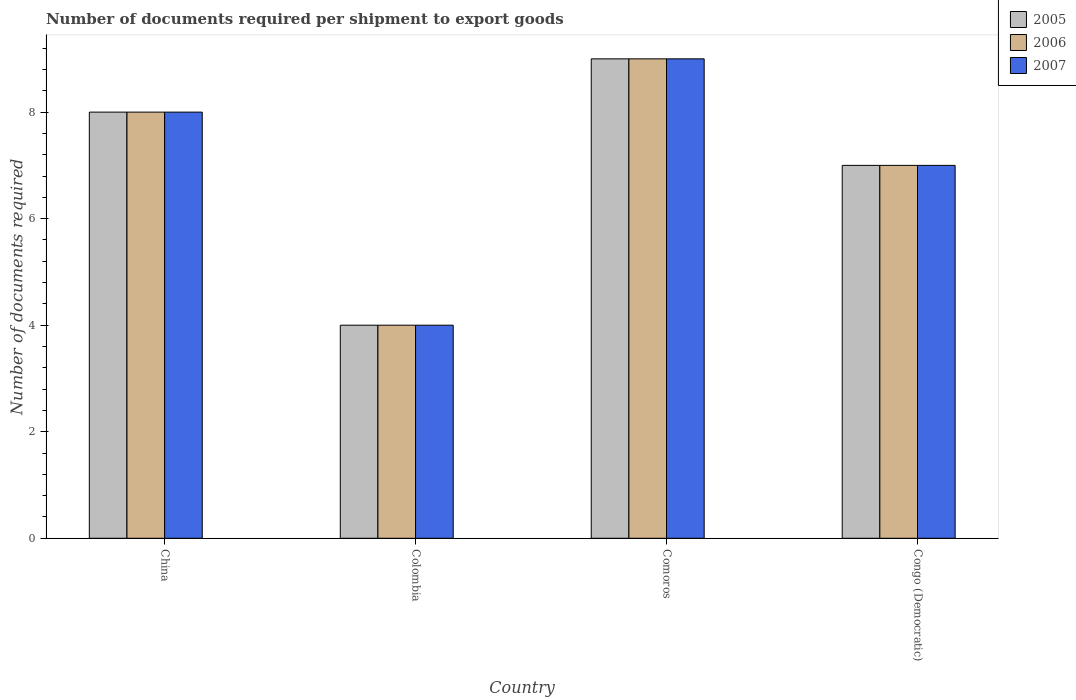How many different coloured bars are there?
Your response must be concise. 3. How many groups of bars are there?
Your answer should be very brief. 4. Are the number of bars per tick equal to the number of legend labels?
Keep it short and to the point. Yes. Are the number of bars on each tick of the X-axis equal?
Your answer should be compact. Yes. Across all countries, what is the minimum number of documents required per shipment to export goods in 2007?
Your answer should be compact. 4. In which country was the number of documents required per shipment to export goods in 2006 maximum?
Keep it short and to the point. Comoros. What is the total number of documents required per shipment to export goods in 2007 in the graph?
Keep it short and to the point. 28. What is the difference between the number of documents required per shipment to export goods in 2005 in Congo (Democratic) and the number of documents required per shipment to export goods in 2006 in Colombia?
Provide a short and direct response. 3. What is the average number of documents required per shipment to export goods in 2006 per country?
Make the answer very short. 7. In how many countries, is the number of documents required per shipment to export goods in 2005 greater than 5.2?
Offer a very short reply. 3. What is the ratio of the number of documents required per shipment to export goods in 2005 in China to that in Congo (Democratic)?
Give a very brief answer. 1.14. Is the number of documents required per shipment to export goods in 2005 in Comoros less than that in Congo (Democratic)?
Your response must be concise. No. What is the difference between the highest and the second highest number of documents required per shipment to export goods in 2005?
Give a very brief answer. -1. Are all the bars in the graph horizontal?
Ensure brevity in your answer.  No. What is the difference between two consecutive major ticks on the Y-axis?
Provide a succinct answer. 2. Are the values on the major ticks of Y-axis written in scientific E-notation?
Ensure brevity in your answer.  No. Where does the legend appear in the graph?
Make the answer very short. Top right. How many legend labels are there?
Give a very brief answer. 3. How are the legend labels stacked?
Offer a terse response. Vertical. What is the title of the graph?
Keep it short and to the point. Number of documents required per shipment to export goods. What is the label or title of the X-axis?
Your answer should be very brief. Country. What is the label or title of the Y-axis?
Make the answer very short. Number of documents required. What is the Number of documents required in 2007 in China?
Make the answer very short. 8. What is the Number of documents required of 2007 in Colombia?
Your response must be concise. 4. What is the Number of documents required of 2006 in Comoros?
Keep it short and to the point. 9. What is the Number of documents required of 2007 in Comoros?
Ensure brevity in your answer.  9. What is the Number of documents required in 2006 in Congo (Democratic)?
Your answer should be very brief. 7. What is the Number of documents required in 2007 in Congo (Democratic)?
Your answer should be compact. 7. Across all countries, what is the maximum Number of documents required of 2006?
Offer a very short reply. 9. Across all countries, what is the minimum Number of documents required of 2007?
Ensure brevity in your answer.  4. What is the total Number of documents required in 2005 in the graph?
Your answer should be compact. 28. What is the total Number of documents required of 2006 in the graph?
Provide a succinct answer. 28. What is the difference between the Number of documents required in 2006 in China and that in Colombia?
Make the answer very short. 4. What is the difference between the Number of documents required of 2007 in China and that in Colombia?
Ensure brevity in your answer.  4. What is the difference between the Number of documents required of 2007 in China and that in Comoros?
Offer a terse response. -1. What is the difference between the Number of documents required in 2005 in China and that in Congo (Democratic)?
Make the answer very short. 1. What is the difference between the Number of documents required of 2006 in Colombia and that in Comoros?
Keep it short and to the point. -5. What is the difference between the Number of documents required in 2007 in Colombia and that in Comoros?
Give a very brief answer. -5. What is the difference between the Number of documents required of 2005 in Colombia and that in Congo (Democratic)?
Offer a terse response. -3. What is the difference between the Number of documents required of 2006 in Colombia and that in Congo (Democratic)?
Your answer should be compact. -3. What is the difference between the Number of documents required in 2007 in Colombia and that in Congo (Democratic)?
Provide a succinct answer. -3. What is the difference between the Number of documents required of 2005 in Comoros and that in Congo (Democratic)?
Your answer should be compact. 2. What is the difference between the Number of documents required in 2006 in Comoros and that in Congo (Democratic)?
Offer a terse response. 2. What is the difference between the Number of documents required of 2005 in China and the Number of documents required of 2007 in Colombia?
Keep it short and to the point. 4. What is the difference between the Number of documents required of 2006 in Colombia and the Number of documents required of 2007 in Congo (Democratic)?
Provide a short and direct response. -3. What is the difference between the Number of documents required in 2005 in Comoros and the Number of documents required in 2006 in Congo (Democratic)?
Keep it short and to the point. 2. What is the difference between the Number of documents required of 2006 in Comoros and the Number of documents required of 2007 in Congo (Democratic)?
Provide a succinct answer. 2. What is the difference between the Number of documents required in 2005 and Number of documents required in 2006 in Colombia?
Provide a succinct answer. 0. What is the difference between the Number of documents required of 2005 and Number of documents required of 2007 in Colombia?
Your response must be concise. 0. What is the difference between the Number of documents required of 2006 and Number of documents required of 2007 in Colombia?
Provide a succinct answer. 0. What is the difference between the Number of documents required of 2005 and Number of documents required of 2006 in Comoros?
Offer a terse response. 0. What is the difference between the Number of documents required of 2005 and Number of documents required of 2007 in Comoros?
Offer a very short reply. 0. What is the difference between the Number of documents required in 2006 and Number of documents required in 2007 in Comoros?
Keep it short and to the point. 0. What is the difference between the Number of documents required in 2005 and Number of documents required in 2007 in Congo (Democratic)?
Provide a short and direct response. 0. What is the difference between the Number of documents required in 2006 and Number of documents required in 2007 in Congo (Democratic)?
Your response must be concise. 0. What is the ratio of the Number of documents required in 2006 in China to that in Colombia?
Ensure brevity in your answer.  2. What is the ratio of the Number of documents required of 2005 in China to that in Comoros?
Your response must be concise. 0.89. What is the ratio of the Number of documents required of 2007 in China to that in Comoros?
Give a very brief answer. 0.89. What is the ratio of the Number of documents required of 2005 in China to that in Congo (Democratic)?
Your response must be concise. 1.14. What is the ratio of the Number of documents required in 2005 in Colombia to that in Comoros?
Provide a succinct answer. 0.44. What is the ratio of the Number of documents required in 2006 in Colombia to that in Comoros?
Your response must be concise. 0.44. What is the ratio of the Number of documents required of 2007 in Colombia to that in Comoros?
Your answer should be compact. 0.44. What is the ratio of the Number of documents required of 2007 in Comoros to that in Congo (Democratic)?
Your response must be concise. 1.29. What is the difference between the highest and the second highest Number of documents required in 2007?
Provide a succinct answer. 1. What is the difference between the highest and the lowest Number of documents required in 2006?
Provide a short and direct response. 5. What is the difference between the highest and the lowest Number of documents required in 2007?
Provide a succinct answer. 5. 